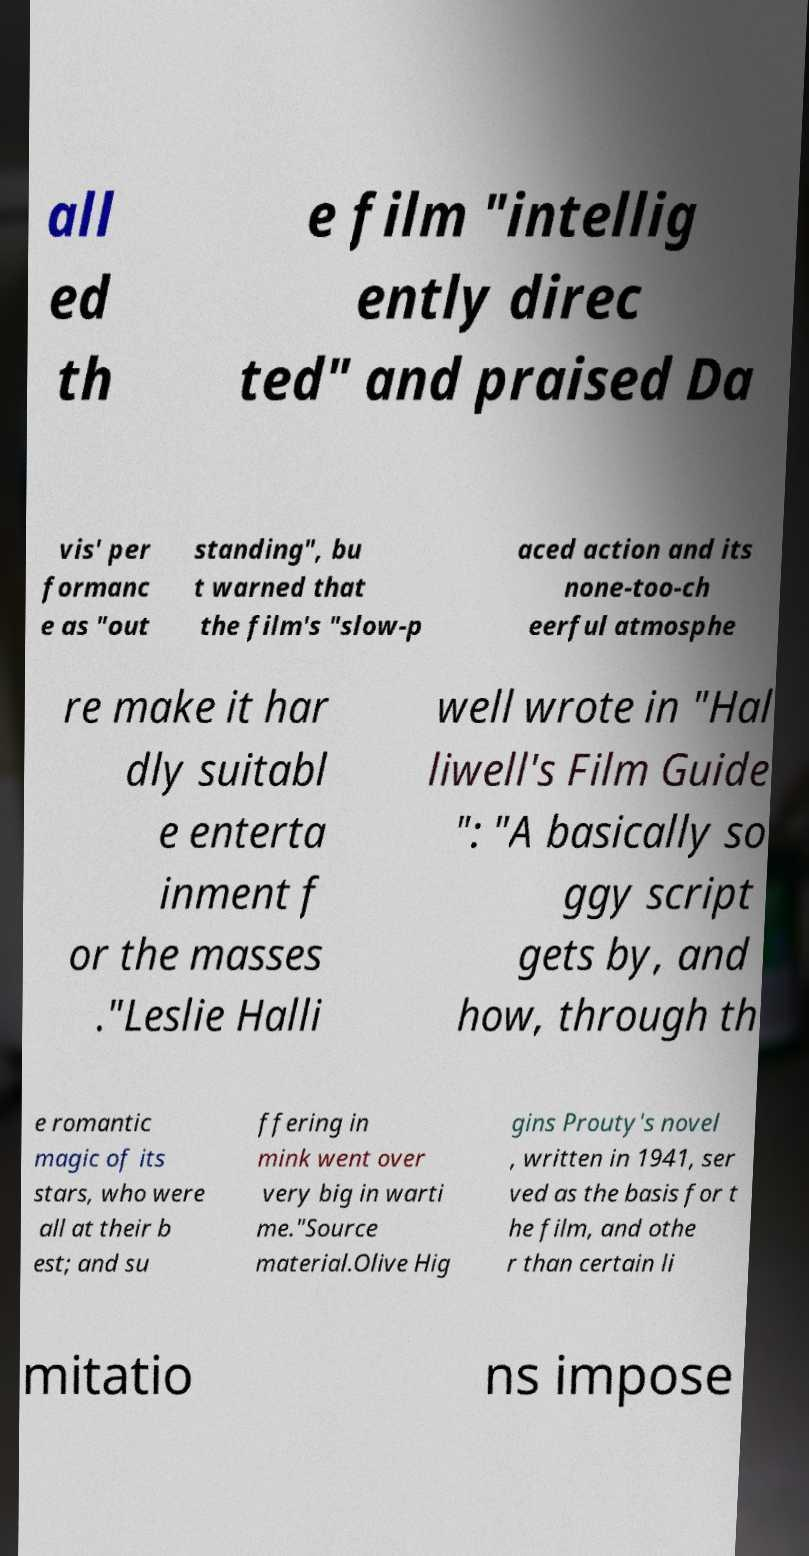For documentation purposes, I need the text within this image transcribed. Could you provide that? all ed th e film "intellig ently direc ted" and praised Da vis' per formanc e as "out standing", bu t warned that the film's "slow-p aced action and its none-too-ch eerful atmosphe re make it har dly suitabl e enterta inment f or the masses ."Leslie Halli well wrote in "Hal liwell's Film Guide ": "A basically so ggy script gets by, and how, through th e romantic magic of its stars, who were all at their b est; and su ffering in mink went over very big in warti me."Source material.Olive Hig gins Prouty's novel , written in 1941, ser ved as the basis for t he film, and othe r than certain li mitatio ns impose 